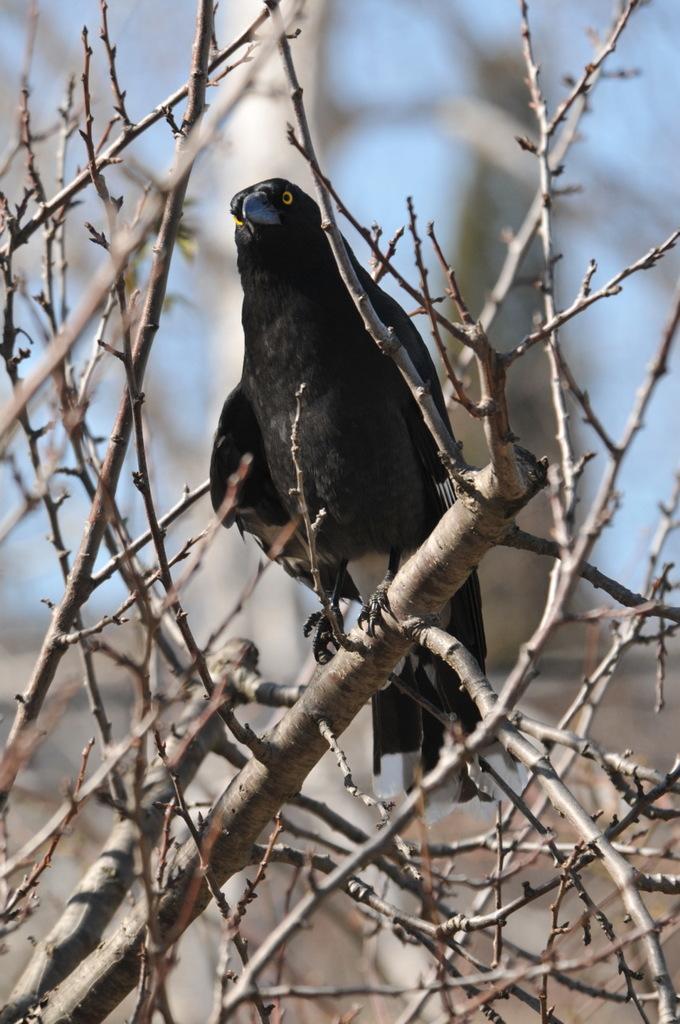In one or two sentences, can you explain what this image depicts? In this image there is a bird standing on the branch of a tree which is in the center and the background is blurry. 